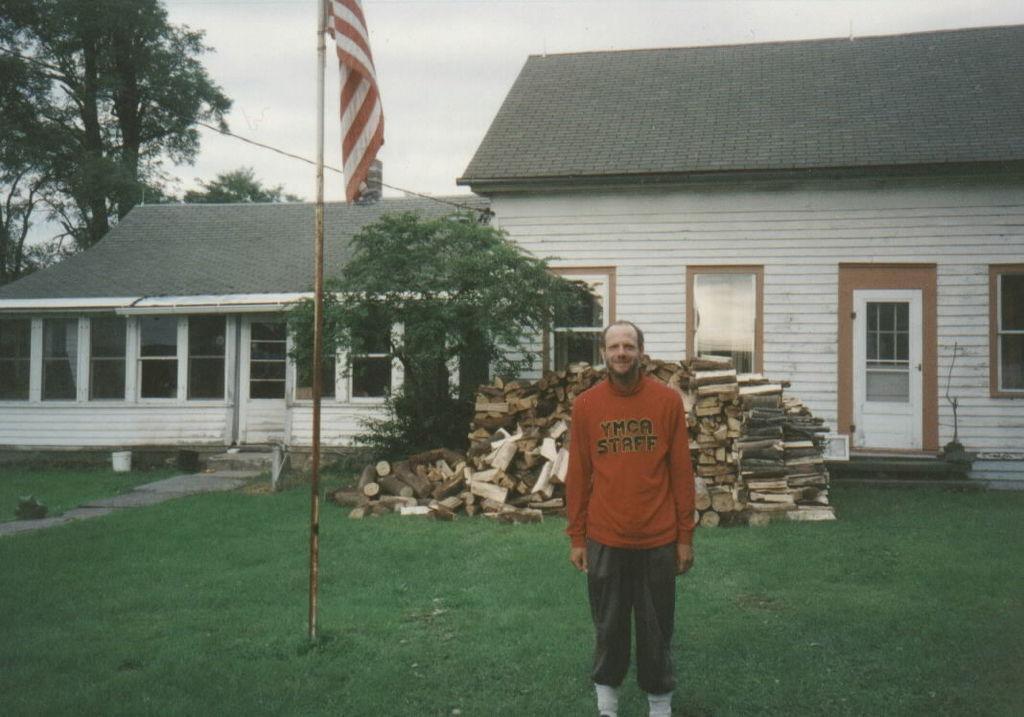Describe this image in one or two sentences. In this image I can see a man is standing. I can see he is wearing orange dress and on it I can see something is written. In the background I can see grass, few trees, few buildings, a pole and a flag. 